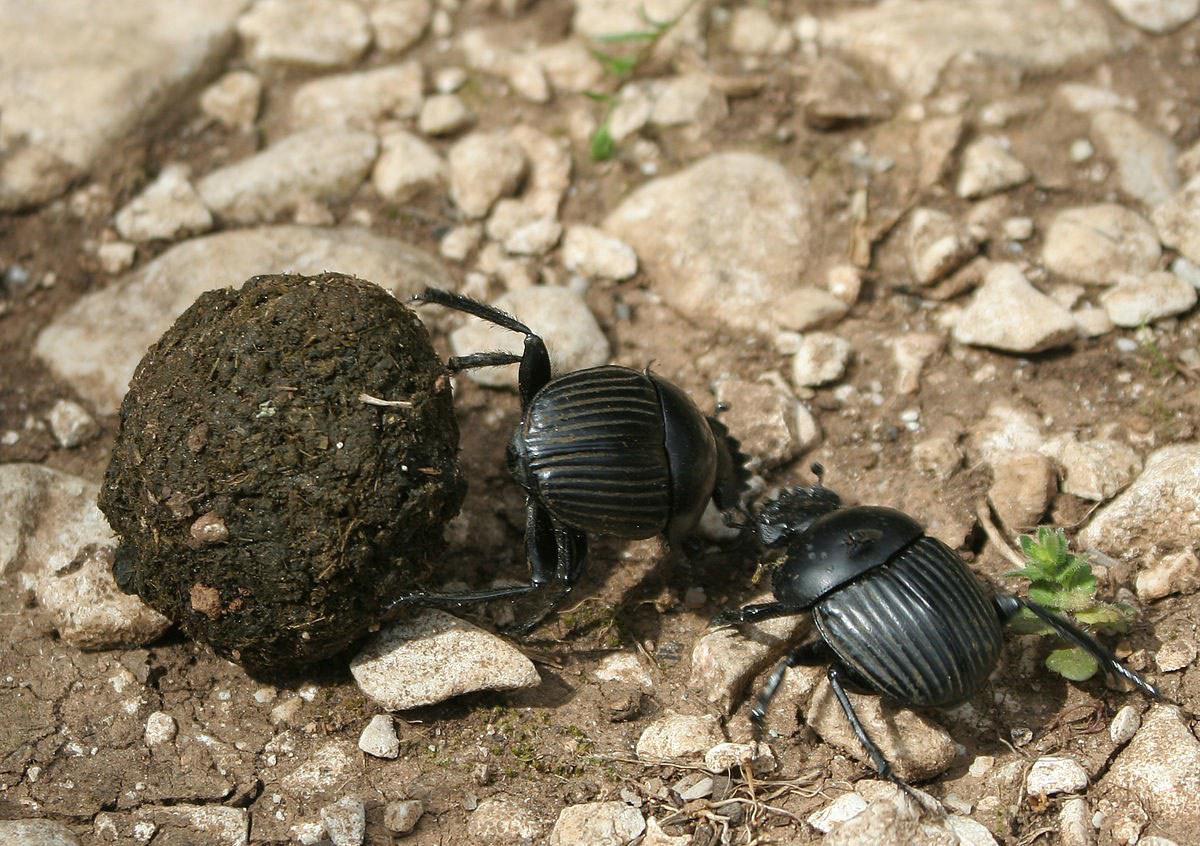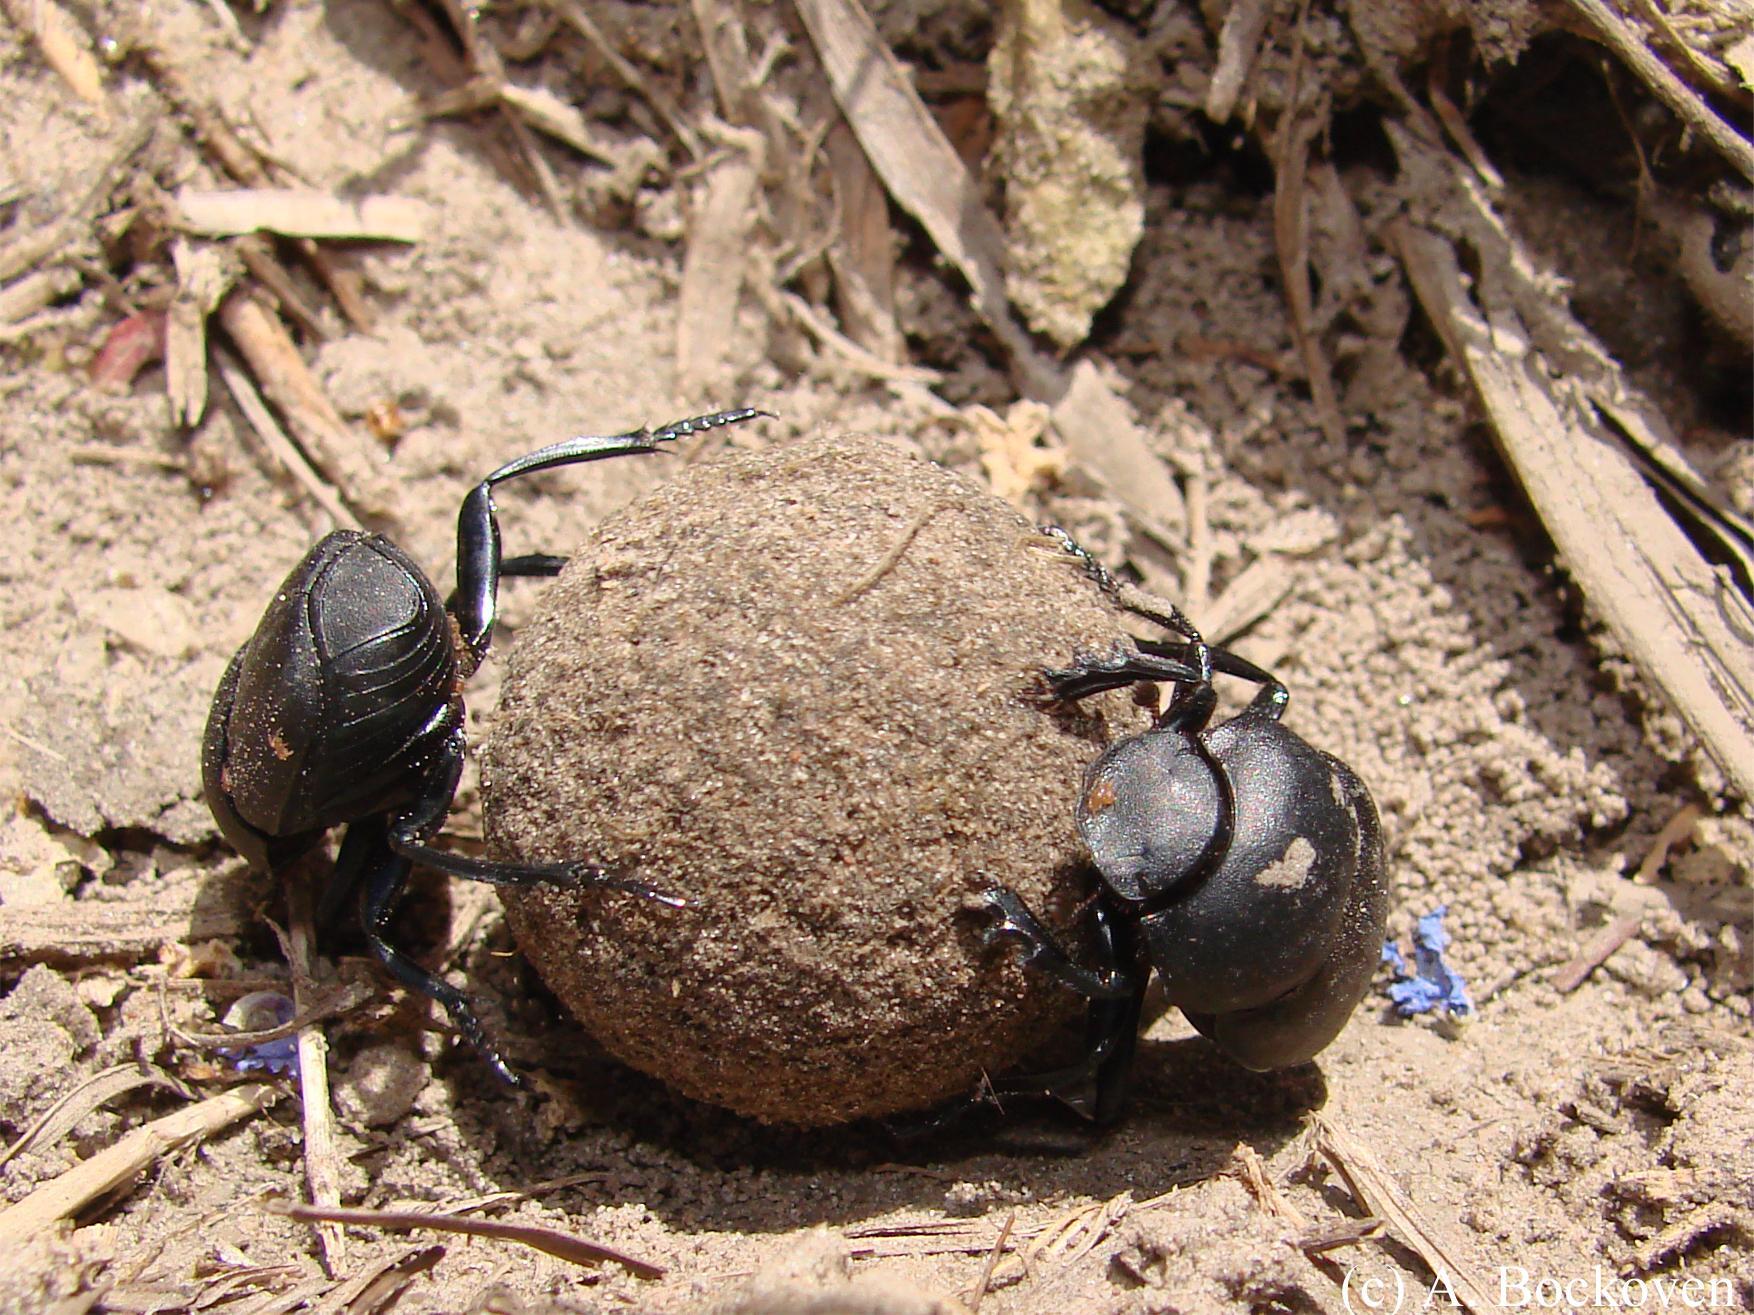The first image is the image on the left, the second image is the image on the right. Given the left and right images, does the statement "There's no more than one dung beetle in the right image." hold true? Answer yes or no. No. The first image is the image on the left, the second image is the image on the right. Assess this claim about the two images: "Two beetles are crawling on the ground in the image on the left.". Correct or not? Answer yes or no. Yes. 